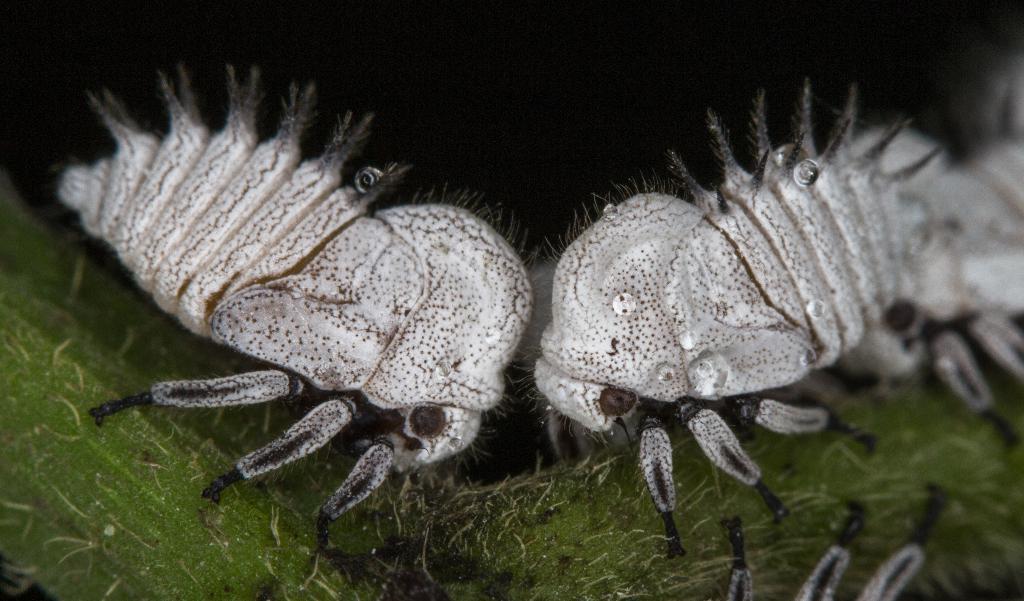Describe this image in one or two sentences. In this image, we can see some insects on the green colored object. We can also see the dark background. 